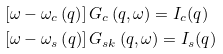<formula> <loc_0><loc_0><loc_500><loc_500>& \left [ \omega - \omega _ { c } \left ( q \right ) \right ] G _ { c } \left ( q , \omega \right ) = I _ { c } ( q ) \\ & \left [ \omega - \omega _ { s } \left ( q \right ) \right ] G _ { s k } \left ( q , \omega \right ) = I _ { s } ( q )</formula> 